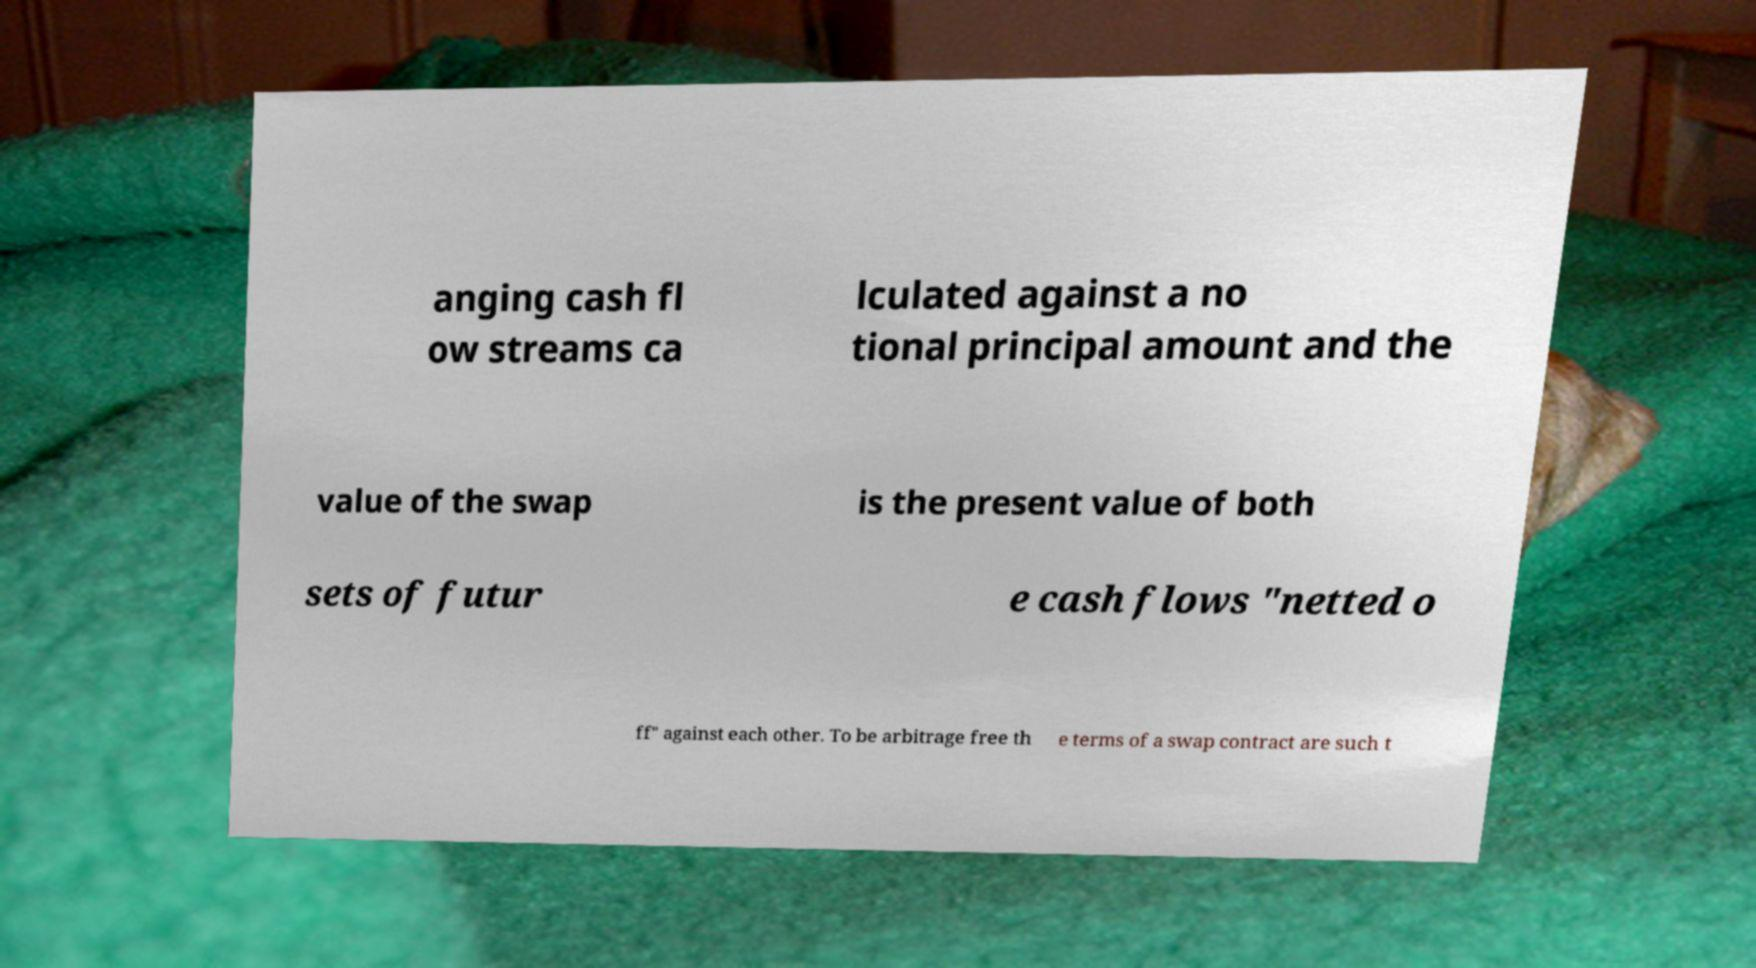There's text embedded in this image that I need extracted. Can you transcribe it verbatim? anging cash fl ow streams ca lculated against a no tional principal amount and the value of the swap is the present value of both sets of futur e cash flows "netted o ff" against each other. To be arbitrage free th e terms of a swap contract are such t 